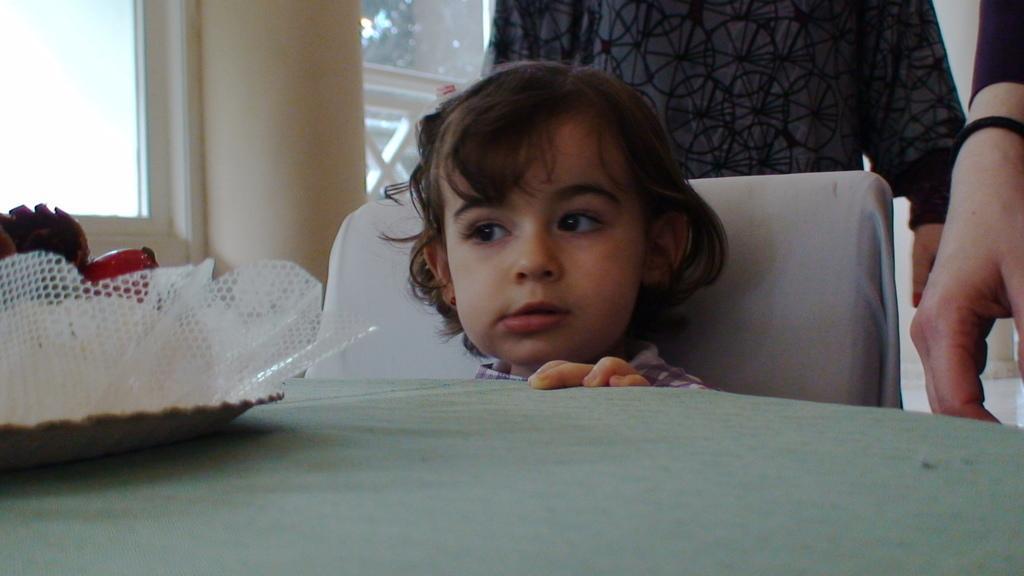Can you describe this image briefly? In this picture there is a kid sitting on a chair, in front of kid we can see objects in a plate on the table, behind kid we can see a person. In the background of the image we can see windows. On the right side of the image we can see a hand of a person. 